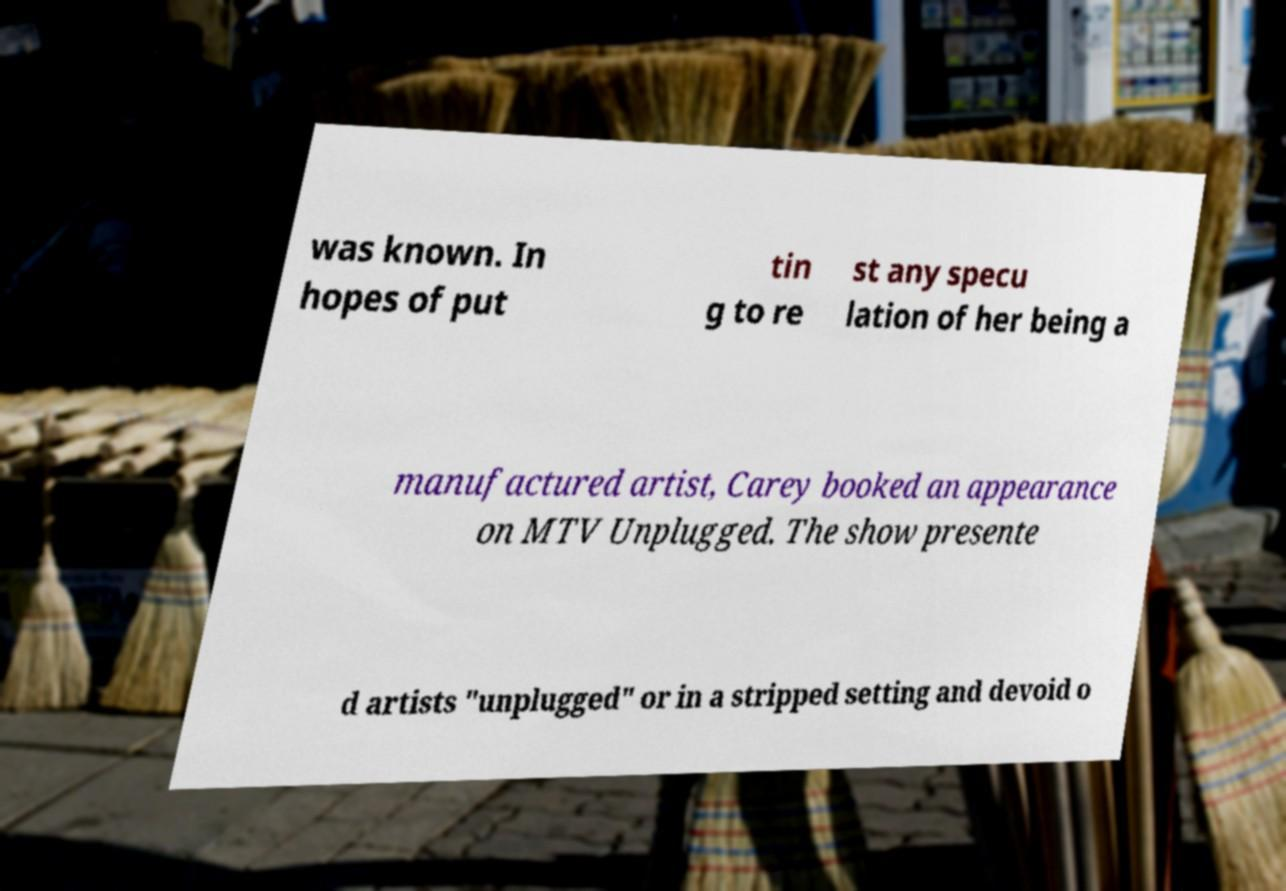Please identify and transcribe the text found in this image. was known. In hopes of put tin g to re st any specu lation of her being a manufactured artist, Carey booked an appearance on MTV Unplugged. The show presente d artists "unplugged" or in a stripped setting and devoid o 